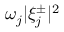<formula> <loc_0><loc_0><loc_500><loc_500>\omega _ { j } | \xi _ { j } ^ { \pm } | ^ { 2 }</formula> 